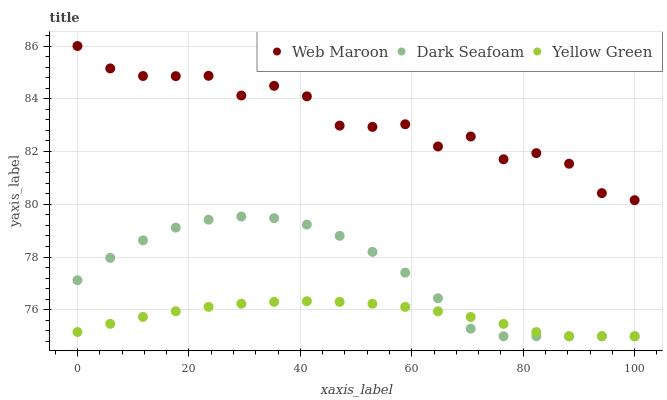Does Yellow Green have the minimum area under the curve?
Answer yes or no. Yes. Does Web Maroon have the maximum area under the curve?
Answer yes or no. Yes. Does Web Maroon have the minimum area under the curve?
Answer yes or no. No. Does Yellow Green have the maximum area under the curve?
Answer yes or no. No. Is Yellow Green the smoothest?
Answer yes or no. Yes. Is Web Maroon the roughest?
Answer yes or no. Yes. Is Web Maroon the smoothest?
Answer yes or no. No. Is Yellow Green the roughest?
Answer yes or no. No. Does Dark Seafoam have the lowest value?
Answer yes or no. Yes. Does Web Maroon have the lowest value?
Answer yes or no. No. Does Web Maroon have the highest value?
Answer yes or no. Yes. Does Yellow Green have the highest value?
Answer yes or no. No. Is Yellow Green less than Web Maroon?
Answer yes or no. Yes. Is Web Maroon greater than Dark Seafoam?
Answer yes or no. Yes. Does Dark Seafoam intersect Yellow Green?
Answer yes or no. Yes. Is Dark Seafoam less than Yellow Green?
Answer yes or no. No. Is Dark Seafoam greater than Yellow Green?
Answer yes or no. No. Does Yellow Green intersect Web Maroon?
Answer yes or no. No. 